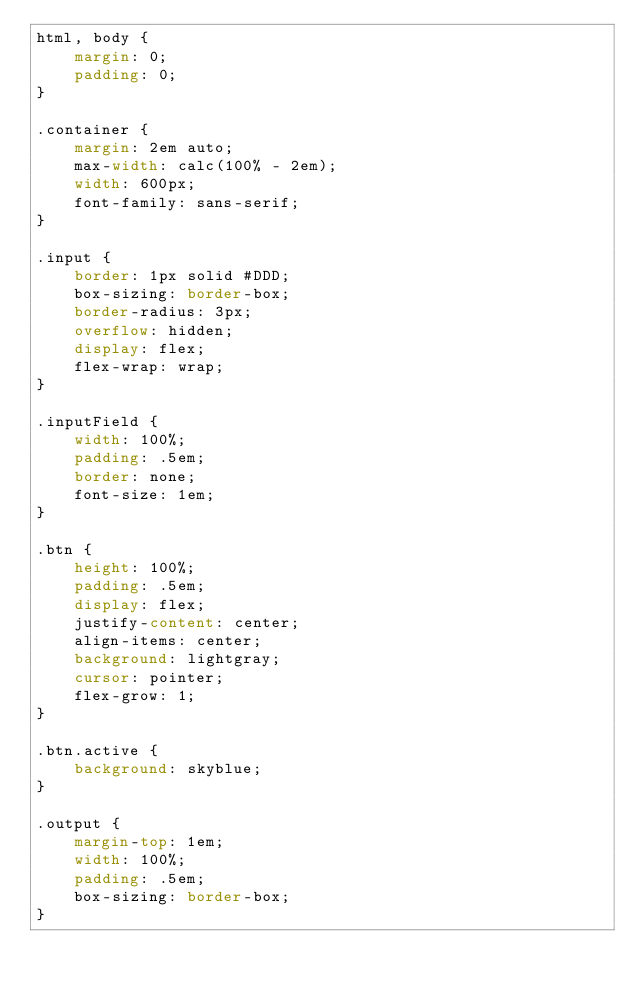<code> <loc_0><loc_0><loc_500><loc_500><_CSS_>html, body {
	margin: 0;
	padding: 0;
}

.container {
	margin: 2em auto;
	max-width: calc(100% - 2em);
	width: 600px;
	font-family: sans-serif;
}

.input {
	border: 1px solid #DDD;
	box-sizing: border-box;
	border-radius: 3px;
	overflow: hidden;
	display: flex;
	flex-wrap: wrap;
}

.inputField {
	width: 100%;
	padding: .5em;
	border: none;
	font-size: 1em;
}

.btn {
	height: 100%;
	padding: .5em;
	display: flex;
	justify-content: center;
	align-items: center;
	background: lightgray;
	cursor: pointer;
	flex-grow: 1;
}

.btn.active {
	background: skyblue;
}

.output {
	margin-top: 1em;
	width: 100%;
	padding: .5em;
	box-sizing: border-box;
}</code> 